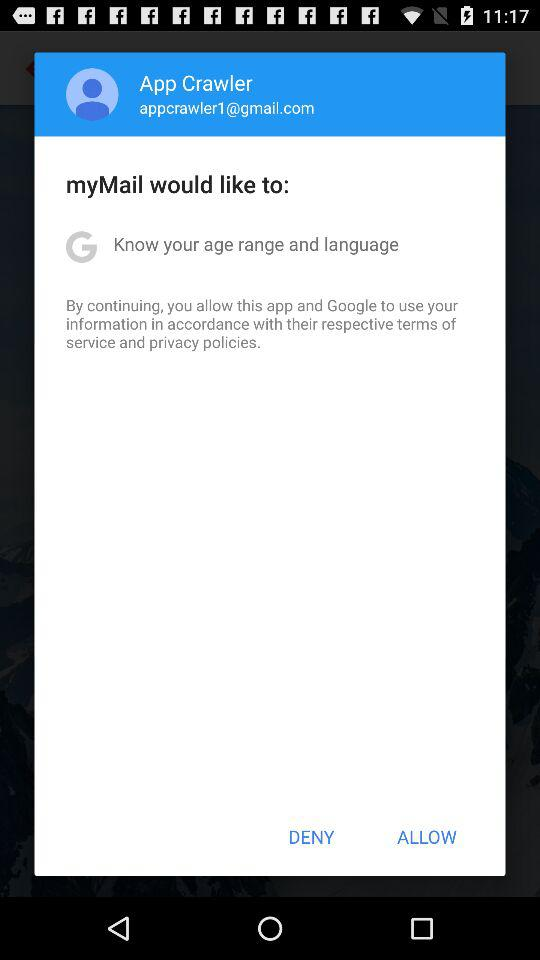What is the user's name? The user's name is App Crawler. 